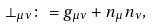<formula> <loc_0><loc_0><loc_500><loc_500>\perp _ { \mu \nu } \colon = g _ { \mu \nu } + n _ { \mu } n _ { \nu } ,</formula> 